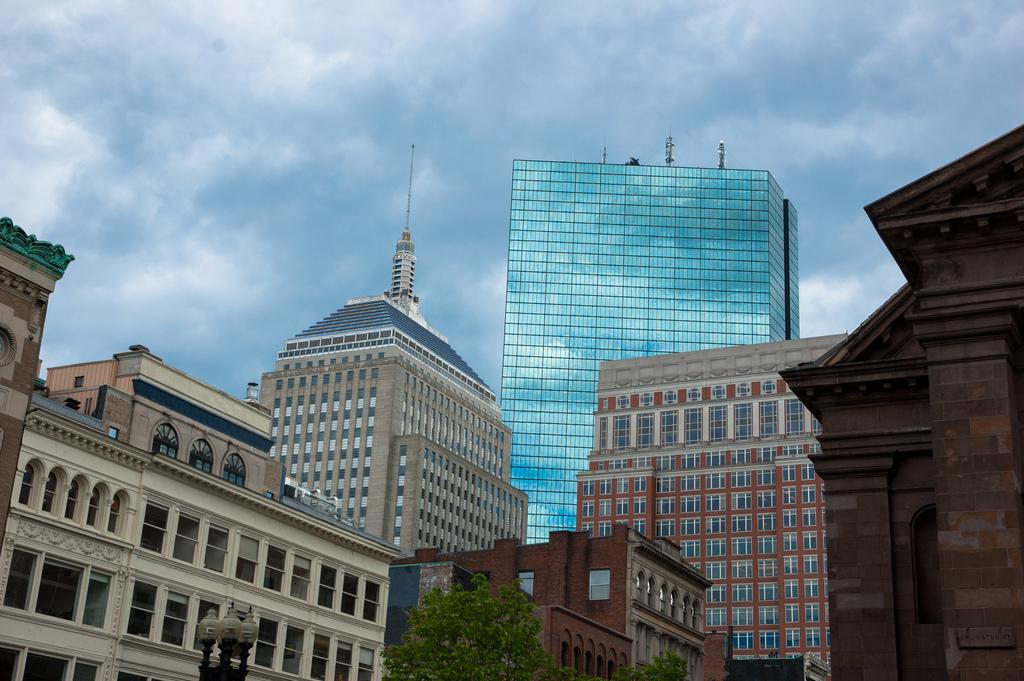What type of structures can be seen in the image? There are buildings in the image. How can the buildings be distinguished from each other? The buildings have different colors. What other natural elements are present in the image? There are trees in the image. What material is used for the windows of the buildings? The buildings have glass windows attached to them. What type of vessel is being used to shade the buildings in the image? There is no vessel present in the image to provide shade for the buildings. 